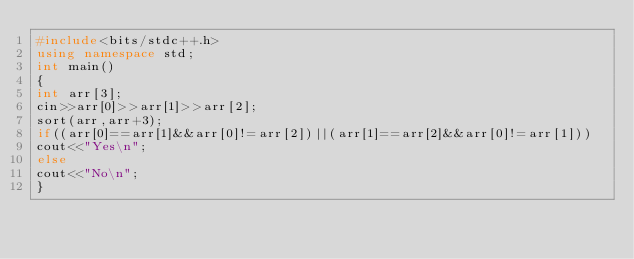<code> <loc_0><loc_0><loc_500><loc_500><_C++_>#include<bits/stdc++.h>
using namespace std;
int main()
{
int arr[3];
cin>>arr[0]>>arr[1]>>arr[2];
sort(arr,arr+3);
if((arr[0]==arr[1]&&arr[0]!=arr[2])||(arr[1]==arr[2]&&arr[0]!=arr[1]))
cout<<"Yes\n";
else
cout<<"No\n";
}
</code> 